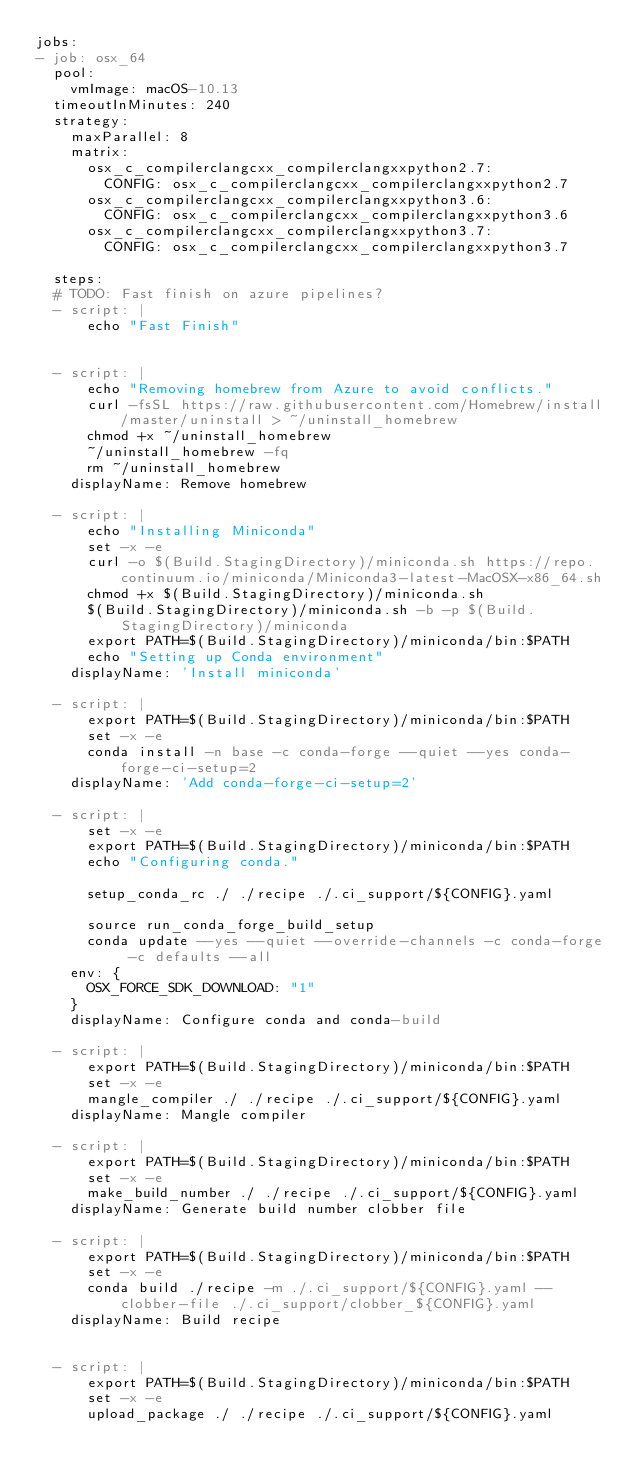Convert code to text. <code><loc_0><loc_0><loc_500><loc_500><_YAML_>jobs:
- job: osx_64
  pool:
    vmImage: macOS-10.13
  timeoutInMinutes: 240
  strategy:
    maxParallel: 8
    matrix:
      osx_c_compilerclangcxx_compilerclangxxpython2.7:
        CONFIG: osx_c_compilerclangcxx_compilerclangxxpython2.7
      osx_c_compilerclangcxx_compilerclangxxpython3.6:
        CONFIG: osx_c_compilerclangcxx_compilerclangxxpython3.6
      osx_c_compilerclangcxx_compilerclangxxpython3.7:
        CONFIG: osx_c_compilerclangcxx_compilerclangxxpython3.7

  steps:
  # TODO: Fast finish on azure pipelines?
  - script: |
      echo "Fast Finish"
      

  - script: |
      echo "Removing homebrew from Azure to avoid conflicts."
      curl -fsSL https://raw.githubusercontent.com/Homebrew/install/master/uninstall > ~/uninstall_homebrew
      chmod +x ~/uninstall_homebrew
      ~/uninstall_homebrew -fq
      rm ~/uninstall_homebrew
    displayName: Remove homebrew

  - script: |
      echo "Installing Miniconda"
      set -x -e
      curl -o $(Build.StagingDirectory)/miniconda.sh https://repo.continuum.io/miniconda/Miniconda3-latest-MacOSX-x86_64.sh
      chmod +x $(Build.StagingDirectory)/miniconda.sh
      $(Build.StagingDirectory)/miniconda.sh -b -p $(Build.StagingDirectory)/miniconda
      export PATH=$(Build.StagingDirectory)/miniconda/bin:$PATH
      echo "Setting up Conda environment"
    displayName: 'Install miniconda'

  - script: |
      export PATH=$(Build.StagingDirectory)/miniconda/bin:$PATH
      set -x -e
      conda install -n base -c conda-forge --quiet --yes conda-forge-ci-setup=2
    displayName: 'Add conda-forge-ci-setup=2'

  - script: |
      set -x -e
      export PATH=$(Build.StagingDirectory)/miniconda/bin:$PATH
      echo "Configuring conda."

      setup_conda_rc ./ ./recipe ./.ci_support/${CONFIG}.yaml

      source run_conda_forge_build_setup
      conda update --yes --quiet --override-channels -c conda-forge -c defaults --all
    env: {
      OSX_FORCE_SDK_DOWNLOAD: "1"
    }
    displayName: Configure conda and conda-build

  - script: |
      export PATH=$(Build.StagingDirectory)/miniconda/bin:$PATH
      set -x -e
      mangle_compiler ./ ./recipe ./.ci_support/${CONFIG}.yaml
    displayName: Mangle compiler

  - script: |
      export PATH=$(Build.StagingDirectory)/miniconda/bin:$PATH
      set -x -e
      make_build_number ./ ./recipe ./.ci_support/${CONFIG}.yaml
    displayName: Generate build number clobber file

  - script: |
      export PATH=$(Build.StagingDirectory)/miniconda/bin:$PATH
      set -x -e
      conda build ./recipe -m ./.ci_support/${CONFIG}.yaml --clobber-file ./.ci_support/clobber_${CONFIG}.yaml
    displayName: Build recipe

  
  - script: |
      export PATH=$(Build.StagingDirectory)/miniconda/bin:$PATH
      set -x -e
      upload_package ./ ./recipe ./.ci_support/${CONFIG}.yaml</code> 